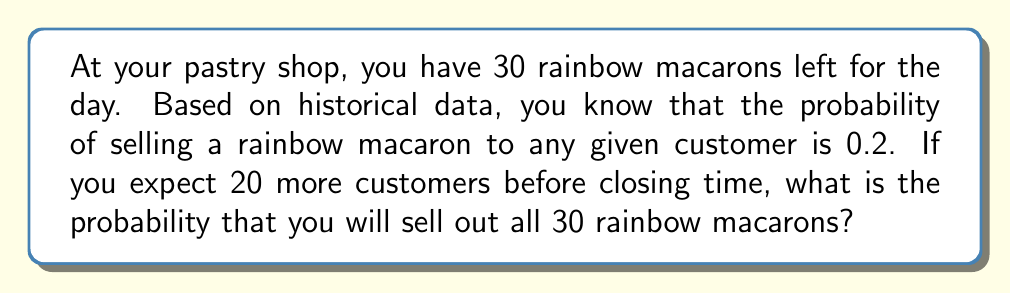Solve this math problem. To solve this problem, we can use the binomial distribution. We need to find the probability of selling at least 30 macarons out of 20 customer visits.

Let X be the random variable representing the number of macarons sold.
n = 20 (number of trials/customers)
p = 0.2 (probability of success for each trial)
k ≥ 30 (we need at least 30 successes to sell out)

The probability of selling out is equal to 1 minus the probability of selling 29 or fewer macarons:

$$P(X \geq 30) = 1 - P(X \leq 29)$$

Since it's impossible to sell more than 20 macarons with only 20 customers, this simplifies to:

$$P(X \geq 30) = 1 - P(X \leq 20) = 0$$

We don't need to calculate the actual binomial probabilities because we know that it's impossible to sell more macarons than the number of customers visiting the shop.

Therefore, the probability of selling out all 30 rainbow macarons is 0.
Answer: 0 